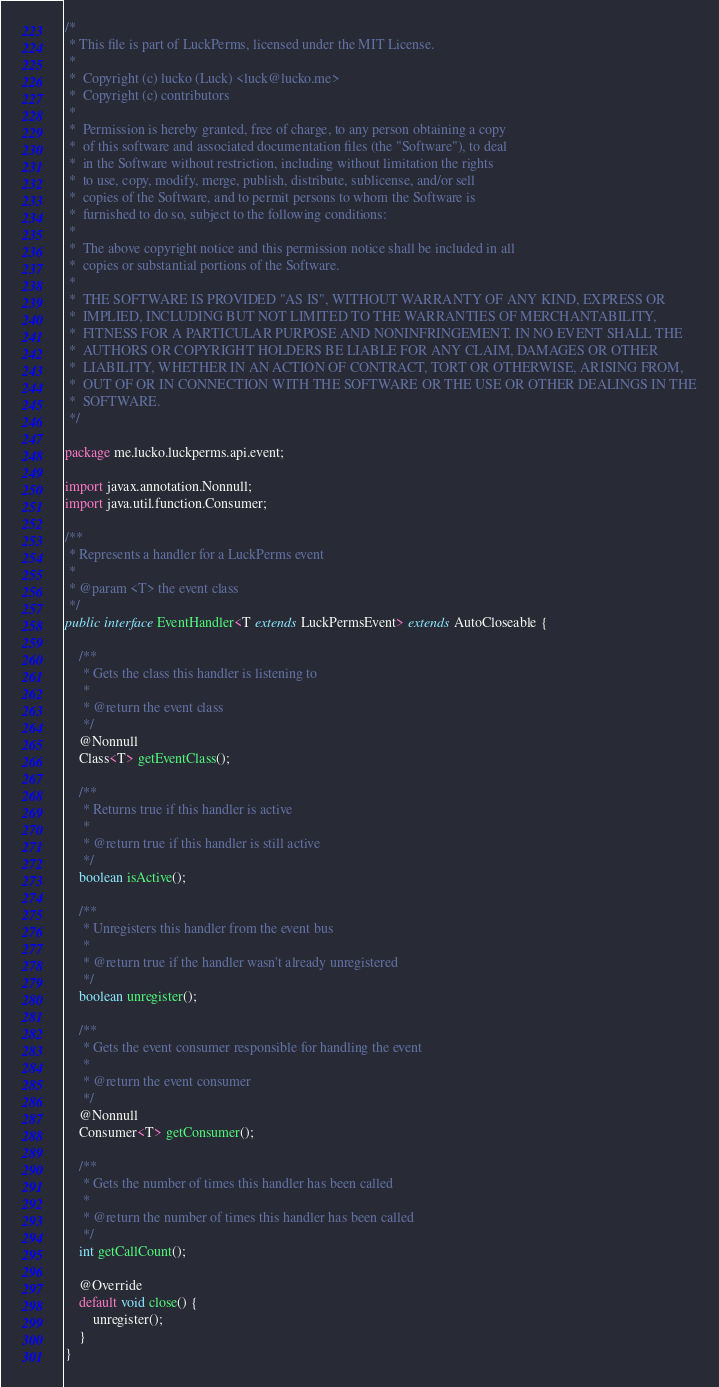<code> <loc_0><loc_0><loc_500><loc_500><_Java_>/*
 * This file is part of LuckPerms, licensed under the MIT License.
 *
 *  Copyright (c) lucko (Luck) <luck@lucko.me>
 *  Copyright (c) contributors
 *
 *  Permission is hereby granted, free of charge, to any person obtaining a copy
 *  of this software and associated documentation files (the "Software"), to deal
 *  in the Software without restriction, including without limitation the rights
 *  to use, copy, modify, merge, publish, distribute, sublicense, and/or sell
 *  copies of the Software, and to permit persons to whom the Software is
 *  furnished to do so, subject to the following conditions:
 *
 *  The above copyright notice and this permission notice shall be included in all
 *  copies or substantial portions of the Software.
 *
 *  THE SOFTWARE IS PROVIDED "AS IS", WITHOUT WARRANTY OF ANY KIND, EXPRESS OR
 *  IMPLIED, INCLUDING BUT NOT LIMITED TO THE WARRANTIES OF MERCHANTABILITY,
 *  FITNESS FOR A PARTICULAR PURPOSE AND NONINFRINGEMENT. IN NO EVENT SHALL THE
 *  AUTHORS OR COPYRIGHT HOLDERS BE LIABLE FOR ANY CLAIM, DAMAGES OR OTHER
 *  LIABILITY, WHETHER IN AN ACTION OF CONTRACT, TORT OR OTHERWISE, ARISING FROM,
 *  OUT OF OR IN CONNECTION WITH THE SOFTWARE OR THE USE OR OTHER DEALINGS IN THE
 *  SOFTWARE.
 */

package me.lucko.luckperms.api.event;

import javax.annotation.Nonnull;
import java.util.function.Consumer;

/**
 * Represents a handler for a LuckPerms event
 *
 * @param <T> the event class
 */
public interface EventHandler<T extends LuckPermsEvent> extends AutoCloseable {

    /**
     * Gets the class this handler is listening to
     *
     * @return the event class
     */
    @Nonnull
    Class<T> getEventClass();

    /**
     * Returns true if this handler is active
     *
     * @return true if this handler is still active
     */
    boolean isActive();

    /**
     * Unregisters this handler from the event bus
     *
     * @return true if the handler wasn't already unregistered
     */
    boolean unregister();

    /**
     * Gets the event consumer responsible for handling the event
     *
     * @return the event consumer
     */
    @Nonnull
    Consumer<T> getConsumer();

    /**
     * Gets the number of times this handler has been called
     *
     * @return the number of times this handler has been called
     */
    int getCallCount();

    @Override
    default void close() {
        unregister();
    }
}
</code> 